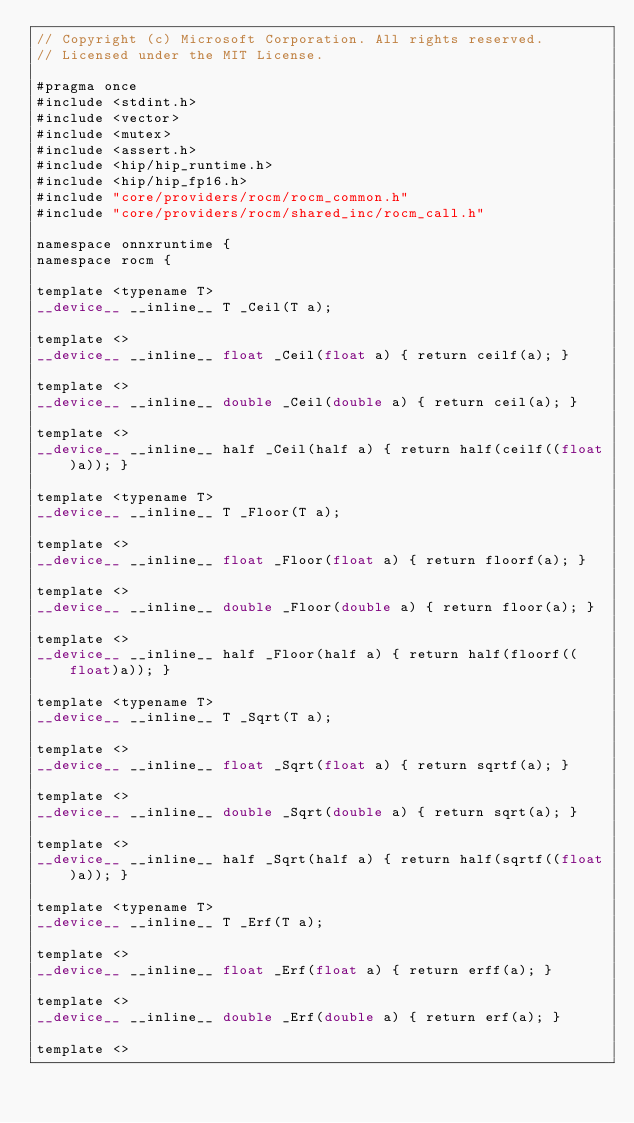<code> <loc_0><loc_0><loc_500><loc_500><_Cuda_>// Copyright (c) Microsoft Corporation. All rights reserved.
// Licensed under the MIT License.

#pragma once
#include <stdint.h>
#include <vector>
#include <mutex>
#include <assert.h>
#include <hip/hip_runtime.h>
#include <hip/hip_fp16.h>
#include "core/providers/rocm/rocm_common.h"
#include "core/providers/rocm/shared_inc/rocm_call.h"

namespace onnxruntime {
namespace rocm {

template <typename T>
__device__ __inline__ T _Ceil(T a);

template <>
__device__ __inline__ float _Ceil(float a) { return ceilf(a); }

template <>
__device__ __inline__ double _Ceil(double a) { return ceil(a); }

template <>
__device__ __inline__ half _Ceil(half a) { return half(ceilf((float)a)); }

template <typename T>
__device__ __inline__ T _Floor(T a);

template <>
__device__ __inline__ float _Floor(float a) { return floorf(a); }

template <>
__device__ __inline__ double _Floor(double a) { return floor(a); }

template <>
__device__ __inline__ half _Floor(half a) { return half(floorf((float)a)); }

template <typename T>
__device__ __inline__ T _Sqrt(T a);

template <>
__device__ __inline__ float _Sqrt(float a) { return sqrtf(a); }

template <>
__device__ __inline__ double _Sqrt(double a) { return sqrt(a); }

template <>
__device__ __inline__ half _Sqrt(half a) { return half(sqrtf((float)a)); }

template <typename T>
__device__ __inline__ T _Erf(T a);

template <>
__device__ __inline__ float _Erf(float a) { return erff(a); }

template <>
__device__ __inline__ double _Erf(double a) { return erf(a); }

template <></code> 